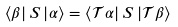<formula> <loc_0><loc_0><loc_500><loc_500>\left \langle \beta \right | S \left | \alpha \right \rangle = \left \langle \mathcal { T } \alpha \right | S \left | \mathcal { T } \beta \right \rangle</formula> 